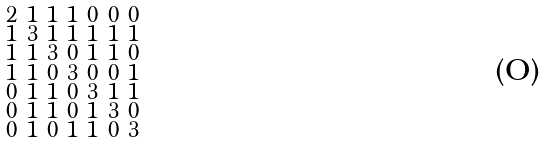<formula> <loc_0><loc_0><loc_500><loc_500>\begin{smallmatrix} 2 & 1 & 1 & 1 & 0 & 0 & 0 \\ 1 & 3 & 1 & 1 & 1 & 1 & 1 \\ 1 & 1 & 3 & 0 & 1 & 1 & 0 \\ 1 & 1 & 0 & 3 & 0 & 0 & 1 \\ 0 & 1 & 1 & 0 & 3 & 1 & 1 \\ 0 & 1 & 1 & 0 & 1 & 3 & 0 \\ 0 & 1 & 0 & 1 & 1 & 0 & 3 \end{smallmatrix}</formula> 